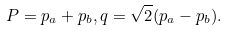<formula> <loc_0><loc_0><loc_500><loc_500>P = p _ { a } + p _ { b } , q = \sqrt { 2 } ( p _ { a } - p _ { b } ) .</formula> 